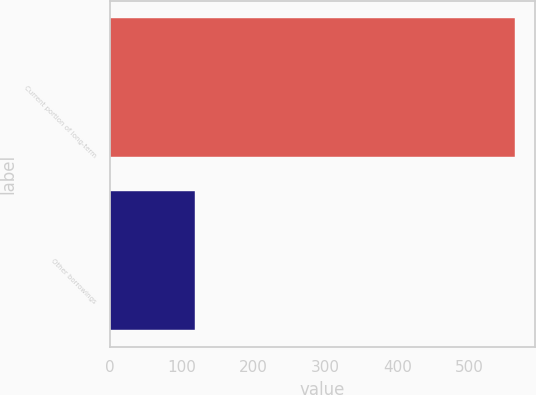<chart> <loc_0><loc_0><loc_500><loc_500><bar_chart><fcel>Current portion of long-term<fcel>Other borrowings<nl><fcel>563<fcel>119<nl></chart> 